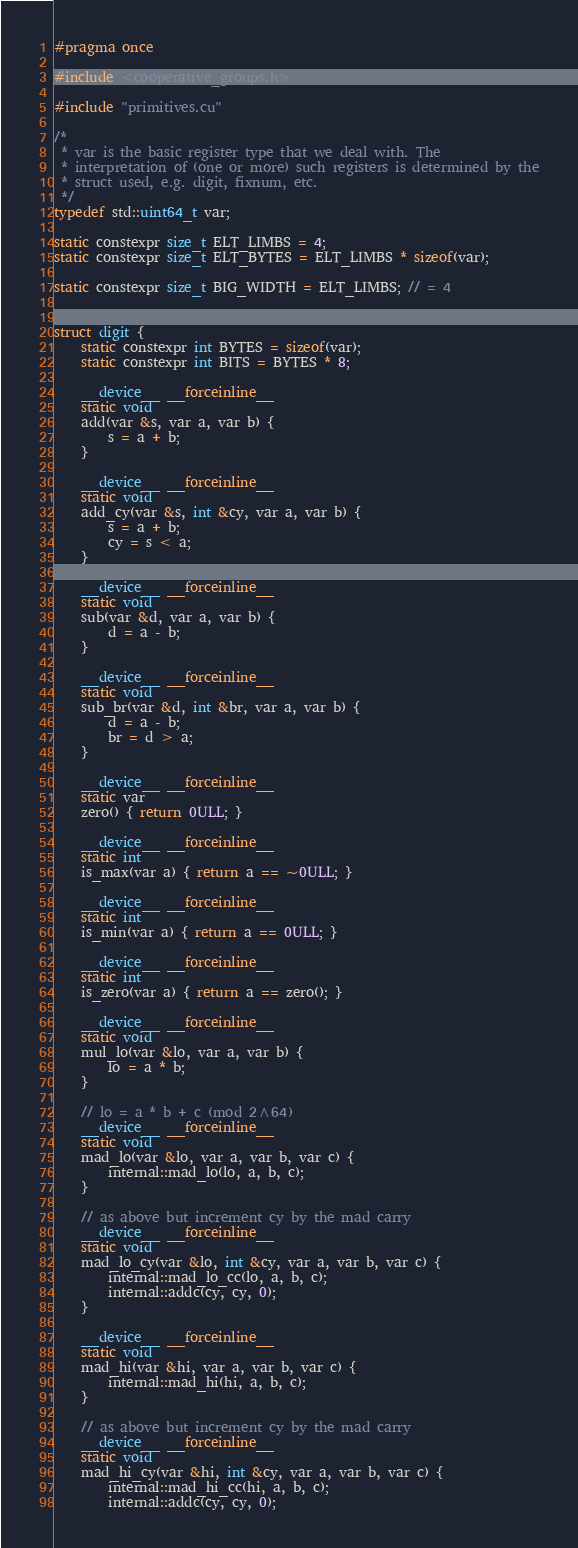<code> <loc_0><loc_0><loc_500><loc_500><_Cuda_>#pragma once

#include <cooperative_groups.h>

#include "primitives.cu"

/*
 * var is the basic register type that we deal with. The
 * interpretation of (one or more) such registers is determined by the
 * struct used, e.g. digit, fixnum, etc.
 */
typedef std::uint64_t var;

static constexpr size_t ELT_LIMBS = 4;
static constexpr size_t ELT_BYTES = ELT_LIMBS * sizeof(var);

static constexpr size_t BIG_WIDTH = ELT_LIMBS; // = 4


struct digit {
    static constexpr int BYTES = sizeof(var);
    static constexpr int BITS = BYTES * 8;

    __device__ __forceinline__
    static void
    add(var &s, var a, var b) {
        s = a + b;
    }

    __device__ __forceinline__
    static void
    add_cy(var &s, int &cy, var a, var b) {
        s = a + b;
        cy = s < a;
    }

    __device__ __forceinline__
    static void
    sub(var &d, var a, var b) {
        d = a - b;
    }

    __device__ __forceinline__
    static void
    sub_br(var &d, int &br, var a, var b) {
        d = a - b;
        br = d > a;
    }

    __device__ __forceinline__
    static var
    zero() { return 0ULL; }

    __device__ __forceinline__
    static int
    is_max(var a) { return a == ~0ULL; }

    __device__ __forceinline__
    static int
    is_min(var a) { return a == 0ULL; }

    __device__ __forceinline__
    static int
    is_zero(var a) { return a == zero(); }

    __device__ __forceinline__
    static void
    mul_lo(var &lo, var a, var b) {
        lo = a * b;
    }

    // lo = a * b + c (mod 2^64)
    __device__ __forceinline__
    static void
    mad_lo(var &lo, var a, var b, var c) {
        internal::mad_lo(lo, a, b, c);
    }

    // as above but increment cy by the mad carry
    __device__ __forceinline__
    static void
    mad_lo_cy(var &lo, int &cy, var a, var b, var c) {
        internal::mad_lo_cc(lo, a, b, c);
        internal::addc(cy, cy, 0);
    }

    __device__ __forceinline__
    static void
    mad_hi(var &hi, var a, var b, var c) {
        internal::mad_hi(hi, a, b, c);
    }

    // as above but increment cy by the mad carry
    __device__ __forceinline__
    static void
    mad_hi_cy(var &hi, int &cy, var a, var b, var c) {
        internal::mad_hi_cc(hi, a, b, c);
        internal::addc(cy, cy, 0);</code> 